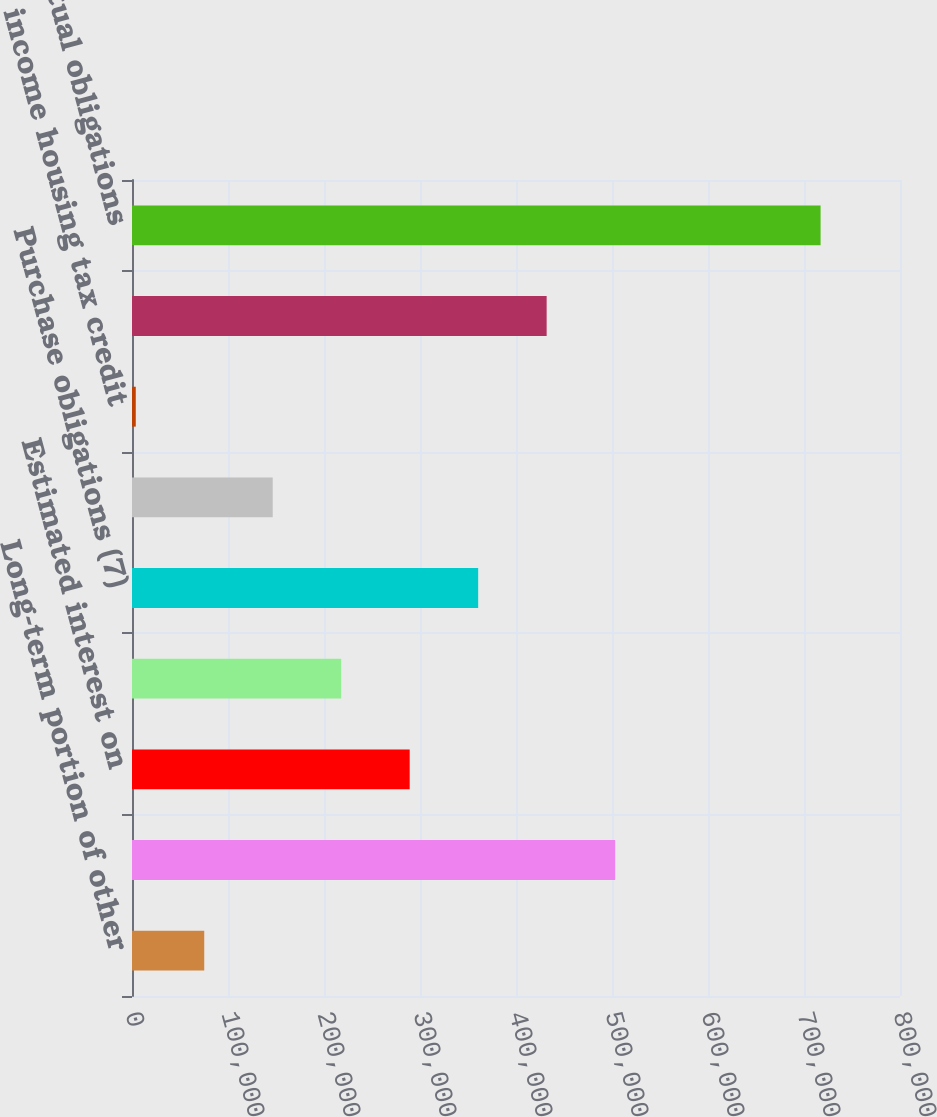Convert chart to OTSL. <chart><loc_0><loc_0><loc_500><loc_500><bar_chart><fcel>Long-term portion of other<fcel>Sub-total long-term debt<fcel>Estimated interest on<fcel>Operating lease obligations<fcel>Purchase obligations (7)<fcel>Deferred compensation programs<fcel>Low income housing tax credit<fcel>Sub-total long-term<fcel>Total contractual obligations<nl><fcel>75246.3<fcel>503264<fcel>289255<fcel>217919<fcel>360592<fcel>146583<fcel>3910<fcel>431928<fcel>717273<nl></chart> 